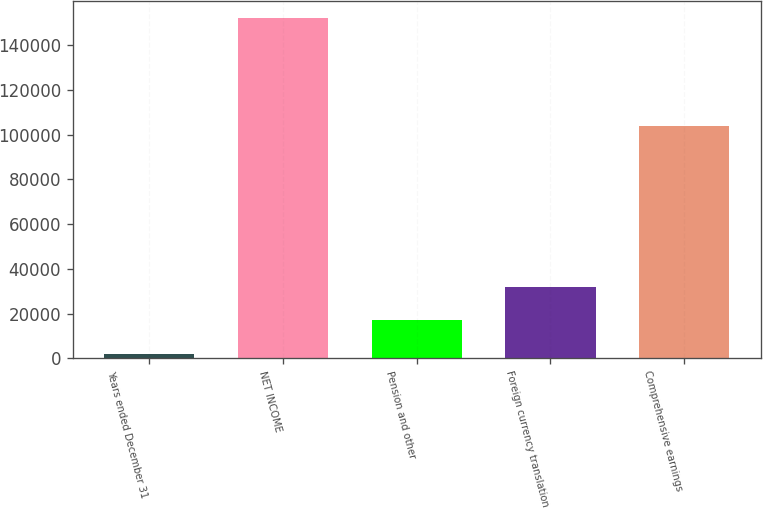Convert chart to OTSL. <chart><loc_0><loc_0><loc_500><loc_500><bar_chart><fcel>Years ended December 31<fcel>NET INCOME<fcel>Pension and other<fcel>Foreign currency translation<fcel>Comprehensive earnings<nl><fcel>2015<fcel>152149<fcel>17028.4<fcel>32041.8<fcel>103947<nl></chart> 